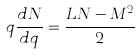<formula> <loc_0><loc_0><loc_500><loc_500>q \frac { d N } { d q } = \frac { L N - M ^ { 2 } } { 2 }</formula> 